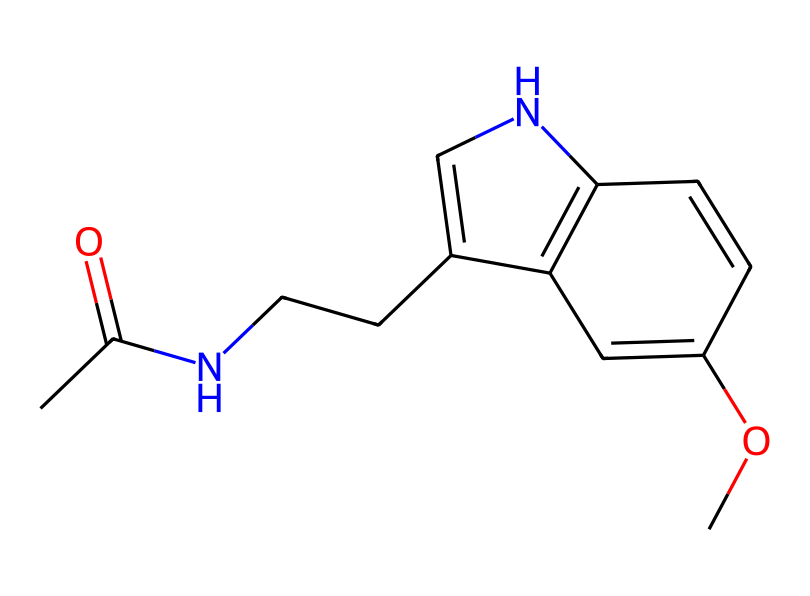What is the chemical name of this compound? The chemical structure corresponds to melatonin, which is a well-known hormone involved in the regulation of sleep. The attached side groups and overall arrangement of atoms confirm its identification.
Answer: melatonin How many carbon atoms are in this structure? By examining the SMILES notation and counting the distinct carbon atoms present, it is found that there are eleven carbon (C) atoms illustrated in the structure.
Answer: eleven What type of functional group is present in this compound? Looking at the structure, one can identify an amide group (-C(=O)N-), suggested by the presence of the carbonyl adjacent to a nitrogen atom, indicating a functional group characteristic to melatonin that contributes to its biological activity.
Answer: amide How many double bonds are present in this compound? Analyzing the structure, the compound has several carbon-carbon double bonds, specifically five in total, as each double bond is denoted by the '=' symbol in the SMILES representation and can be visualized in the structure itself.
Answer: five Is this compound considered a hormone? The chemical structure and its known biological role reveal that melatonin is indeed classified as a hormone since it is produced in the pineal gland and regulates sleep-wake cycles, affecting various physiological processes in the body.
Answer: yes What is the primary biological role of this compound? The structure directly correlates to its function; melatonin is primarily known for its role in regulating sleep patterns, especially in those with disrupted circadian rhythms. It aids in signaling the body for sleep.
Answer: sleep regulation 